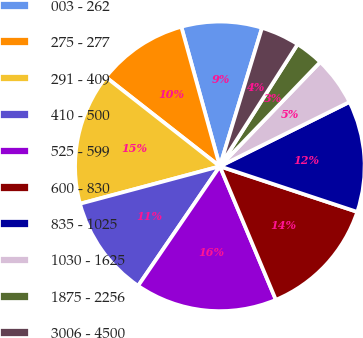Convert chart to OTSL. <chart><loc_0><loc_0><loc_500><loc_500><pie_chart><fcel>003 - 262<fcel>275 - 277<fcel>291 - 409<fcel>410 - 500<fcel>525 - 599<fcel>600 - 830<fcel>835 - 1025<fcel>1030 - 1625<fcel>1875 - 2256<fcel>3006 - 4500<nl><fcel>8.99%<fcel>10.14%<fcel>14.73%<fcel>11.29%<fcel>15.87%<fcel>13.58%<fcel>12.43%<fcel>5.47%<fcel>3.17%<fcel>4.32%<nl></chart> 